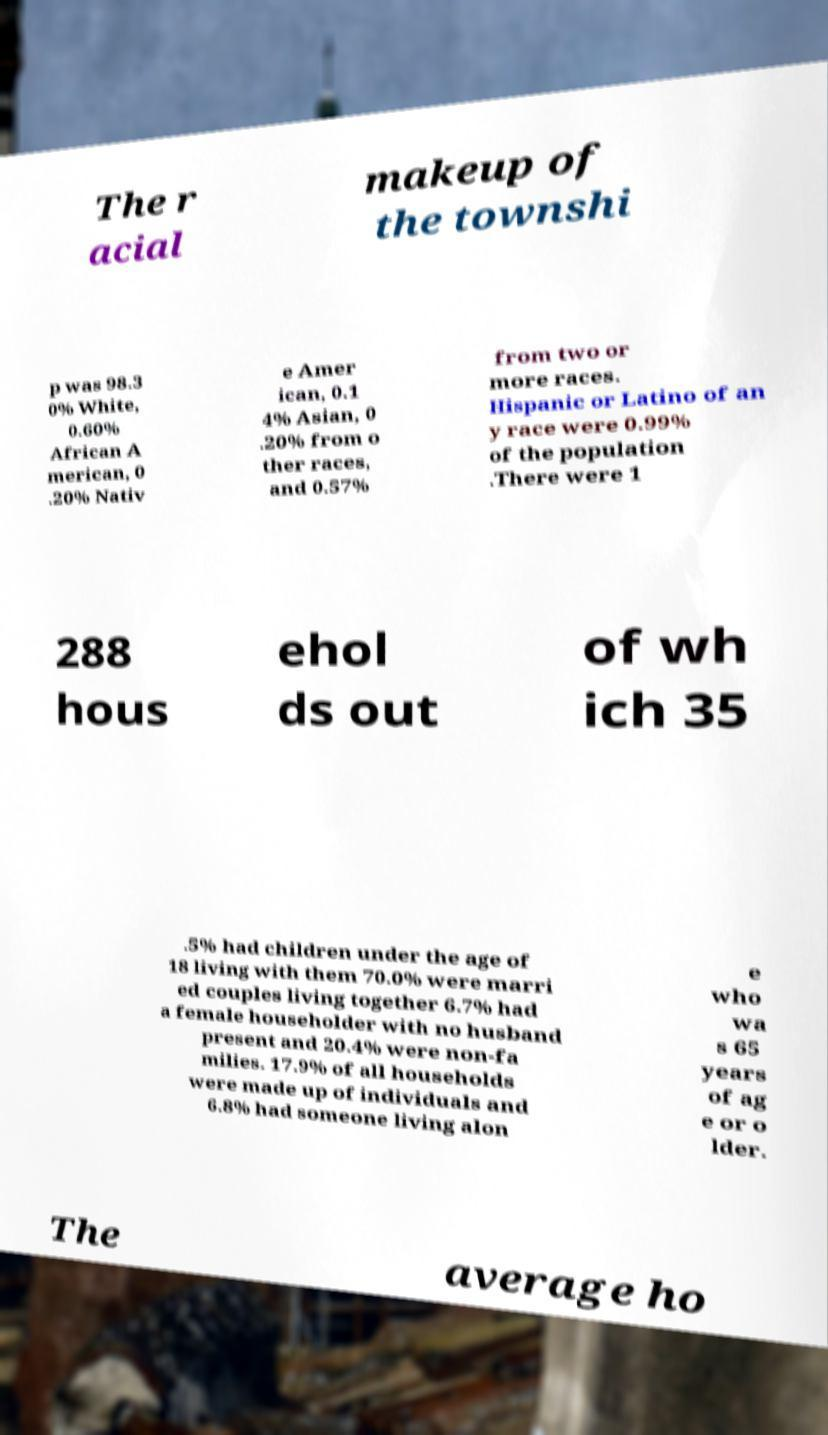Could you assist in decoding the text presented in this image and type it out clearly? The r acial makeup of the townshi p was 98.3 0% White, 0.60% African A merican, 0 .20% Nativ e Amer ican, 0.1 4% Asian, 0 .20% from o ther races, and 0.57% from two or more races. Hispanic or Latino of an y race were 0.99% of the population .There were 1 288 hous ehol ds out of wh ich 35 .5% had children under the age of 18 living with them 70.0% were marri ed couples living together 6.7% had a female householder with no husband present and 20.4% were non-fa milies. 17.9% of all households were made up of individuals and 6.8% had someone living alon e who wa s 65 years of ag e or o lder. The average ho 